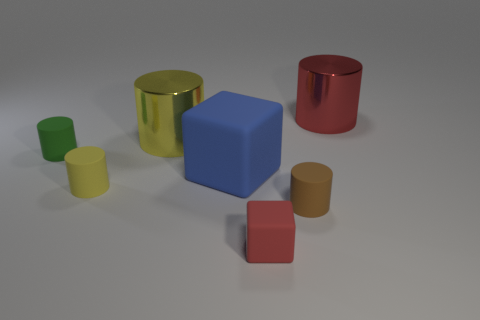Subtract all large yellow metallic cylinders. How many cylinders are left? 4 Subtract all brown cylinders. How many cylinders are left? 4 Subtract all gray cylinders. Subtract all gray blocks. How many cylinders are left? 5 Add 3 yellow shiny objects. How many objects exist? 10 Subtract all cubes. How many objects are left? 5 Subtract 0 blue spheres. How many objects are left? 7 Subtract all small matte cylinders. Subtract all green matte cylinders. How many objects are left? 3 Add 4 tiny green cylinders. How many tiny green cylinders are left? 5 Add 5 blue matte cubes. How many blue matte cubes exist? 6 